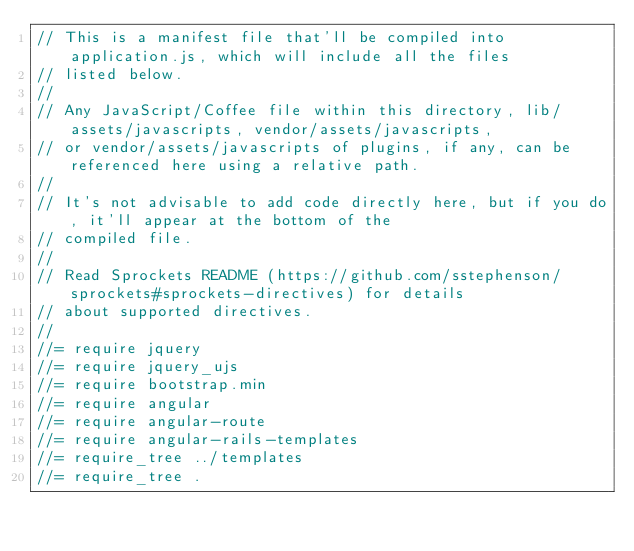Convert code to text. <code><loc_0><loc_0><loc_500><loc_500><_JavaScript_>// This is a manifest file that'll be compiled into application.js, which will include all the files
// listed below.
//
// Any JavaScript/Coffee file within this directory, lib/assets/javascripts, vendor/assets/javascripts,
// or vendor/assets/javascripts of plugins, if any, can be referenced here using a relative path.
//
// It's not advisable to add code directly here, but if you do, it'll appear at the bottom of the
// compiled file.
//
// Read Sprockets README (https://github.com/sstephenson/sprockets#sprockets-directives) for details
// about supported directives.
//
//= require jquery
//= require jquery_ujs
//= require bootstrap.min
//= require angular
//= require angular-route
//= require angular-rails-templates
//= require_tree ../templates
//= require_tree .
</code> 